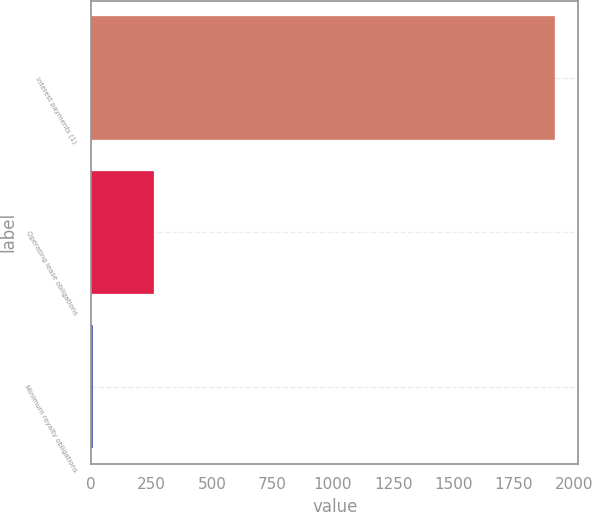Convert chart. <chart><loc_0><loc_0><loc_500><loc_500><bar_chart><fcel>Interest payments (1)<fcel>Operating lease obligations<fcel>Minimum royalty obligations<nl><fcel>1921<fcel>259<fcel>8<nl></chart> 